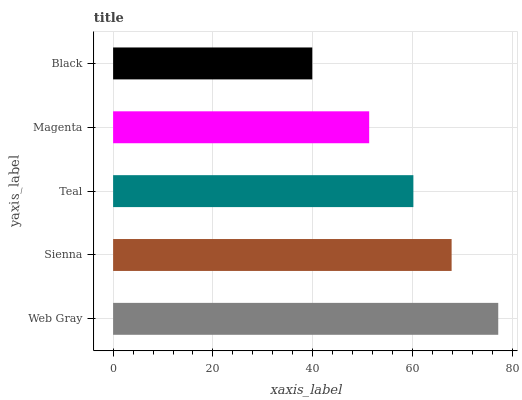Is Black the minimum?
Answer yes or no. Yes. Is Web Gray the maximum?
Answer yes or no. Yes. Is Sienna the minimum?
Answer yes or no. No. Is Sienna the maximum?
Answer yes or no. No. Is Web Gray greater than Sienna?
Answer yes or no. Yes. Is Sienna less than Web Gray?
Answer yes or no. Yes. Is Sienna greater than Web Gray?
Answer yes or no. No. Is Web Gray less than Sienna?
Answer yes or no. No. Is Teal the high median?
Answer yes or no. Yes. Is Teal the low median?
Answer yes or no. Yes. Is Web Gray the high median?
Answer yes or no. No. Is Black the low median?
Answer yes or no. No. 